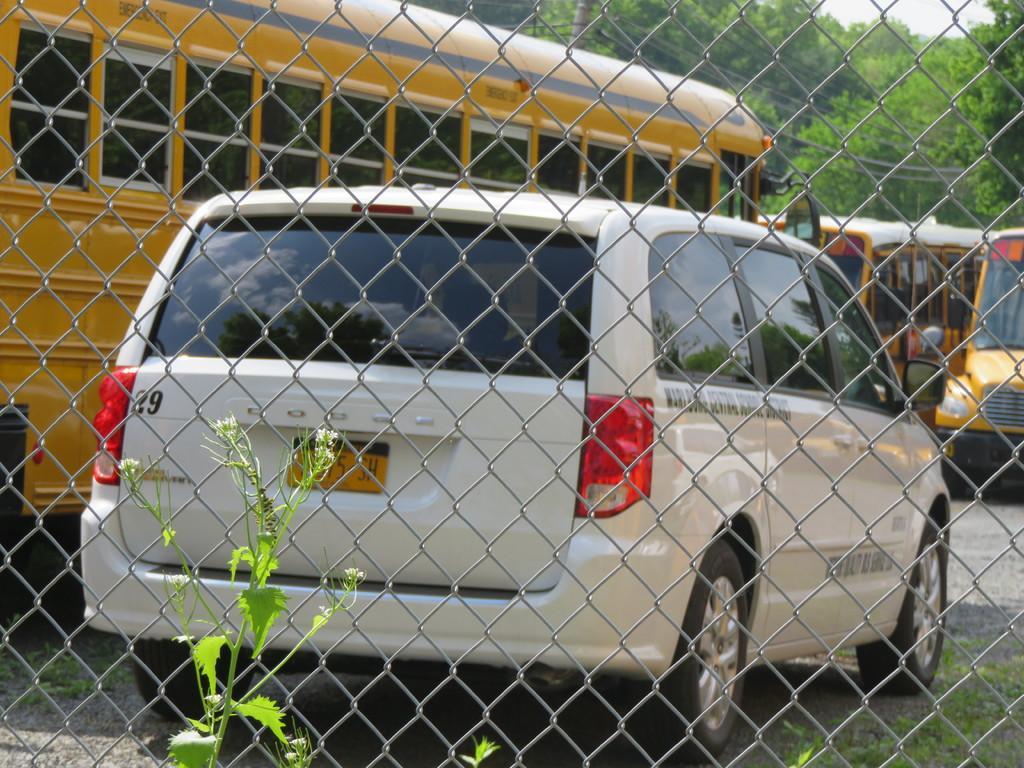Please provide a concise description of this image. Here we can see a welded wire mesh, vehicles, plant, and grass. In the background there are trees and sky. 